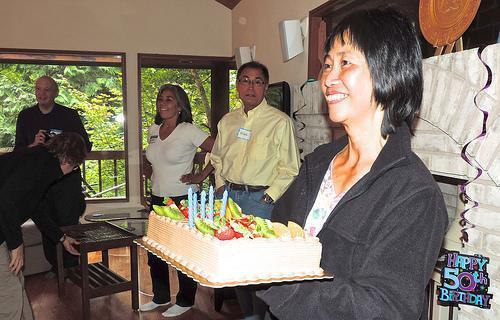How many people are there?
Give a very brief answer. 4. How many candles are on the cake?
Give a very brief answer. 5. How many men are in the photo?
Give a very brief answer. 2. 